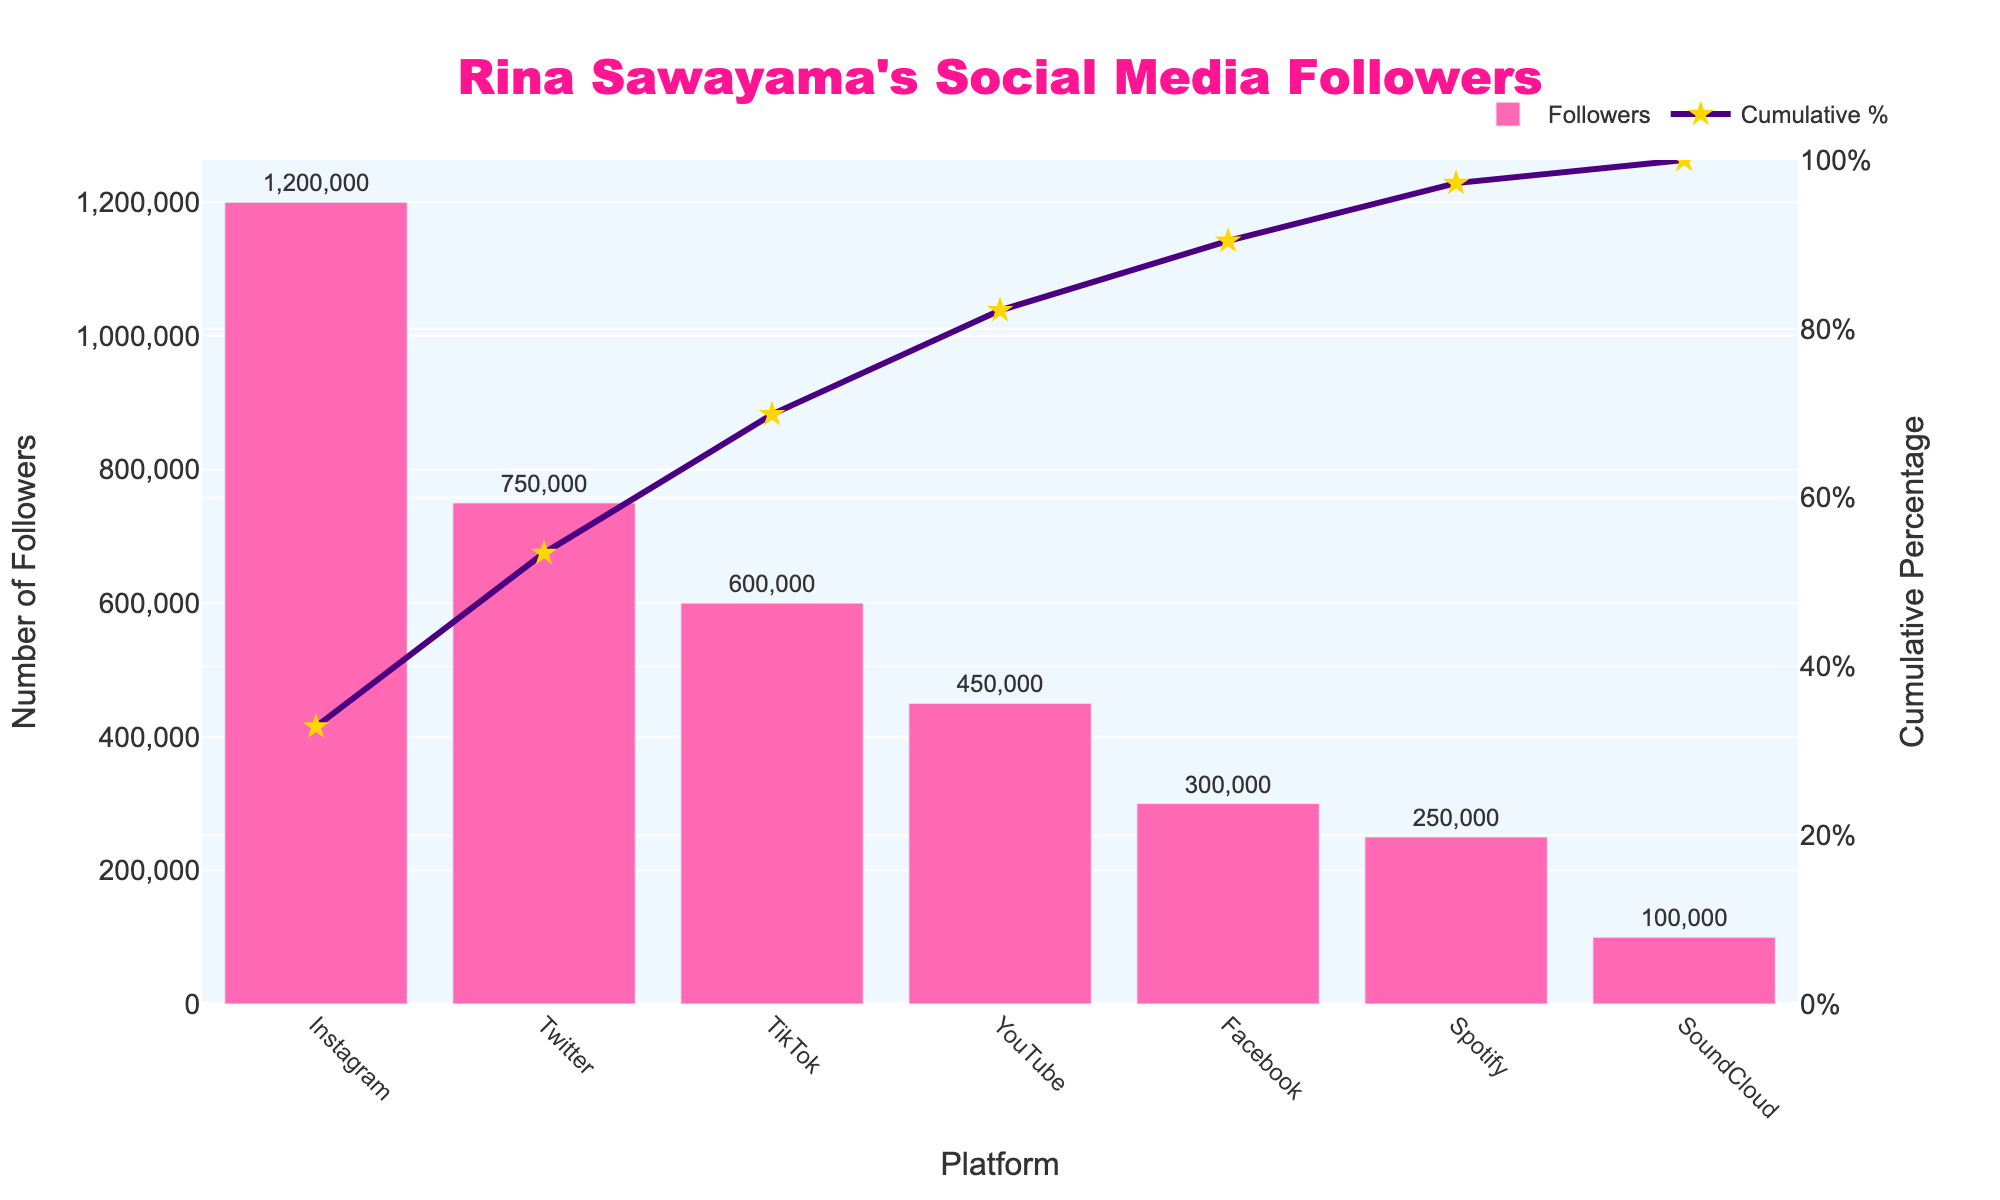What is the title of the figure? The title is prominently displayed at the top center of the figure. It reads "Rina Sawayama's Social Media Followers."
Answer: Rina Sawayama's Social Media Followers Which platform has the highest number of followers? The highest bar in the figure, colored in pink, represents the platform with the highest number of followers.
Answer: Instagram What is the cumulative percentage of followers for the two platforms with the most followers? The platforms with the most followers are Instagram and Twitter. The cumulative percentages are around 45% (Instagram) and 74% (Twitter). Adding these gives approximately 119%.
Answer: 74% How many followers does Rina Sawayama have on TikTok? The value for TikTok is marked on the vertical axis beside the TikTok label and on top of the bar itself.
Answer: 600,000 How does the cumulative percentage trend change after the first three platforms? After Instagram, Twitter, and TikTok, the line graph showing cumulative percentage starts to flatten, indicating smaller contributions from subsequent platforms.
Answer: It starts to flatten Which platform has the lowest number of followers, and how many does it have? The shortest pink bar in the figure represents the platform with the fewest followers.
Answer: SoundCloud with 100,000 followers What is the difference in the number of followers between YouTube and Facebook? The pink bars for YouTube and Facebook are labeled with their follower counts: YouTube has 450,000 and Facebook has 300,000. The difference is 450,000 - 300,000.
Answer: 150,000 followers If Spotify and SoundCloud followers are combined, how does the total compare to Facebook followers? Adding Spotify and SoundCloud followers: 250,000 (Spotify) + 100,000 (SoundCloud) = 350,000. Facebook has 300,000 followers.
Answer: 350,000 (combined) is more than 300,000 (Facebook) What cumulative percentage does Spotify contribute to overall followers? Locate the cumulative percentage point on the secondary vertical axis where the line graph meets the Spotify marker. It's approximately at 98%.
Answer: Approximately 98% By what percentage does Instagram surpass TikTok in terms of followers? Instagram has 1,200,000 followers, while TikTok has 600,000. The percentage difference is calculated by (1,200,000 - 600,000) / 600,000 * 100%.
Answer: 100% 